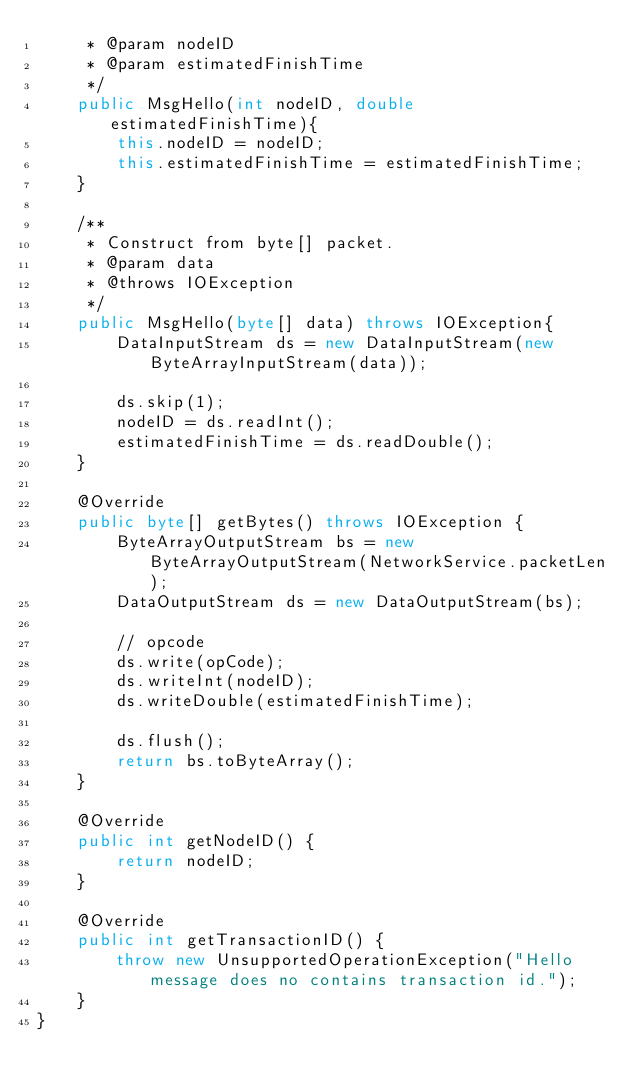<code> <loc_0><loc_0><loc_500><loc_500><_Java_>     * @param nodeID
     * @param estimatedFinishTime
     */
    public MsgHello(int nodeID, double estimatedFinishTime){
        this.nodeID = nodeID;
        this.estimatedFinishTime = estimatedFinishTime;
    }
    
    /**
     * Construct from byte[] packet.
     * @param data
     * @throws IOException 
     */
    public MsgHello(byte[] data) throws IOException{
        DataInputStream ds = new DataInputStream(new ByteArrayInputStream(data));
        
        ds.skip(1);
        nodeID = ds.readInt();
        estimatedFinishTime = ds.readDouble();
    }

    @Override
    public byte[] getBytes() throws IOException {
        ByteArrayOutputStream bs = new ByteArrayOutputStream(NetworkService.packetLen);
        DataOutputStream ds = new DataOutputStream(bs);
        
        // opcode
        ds.write(opCode);
        ds.writeInt(nodeID);
        ds.writeDouble(estimatedFinishTime);
        
        ds.flush();
        return bs.toByteArray();
    }

    @Override
    public int getNodeID() {
        return nodeID;
    }

    @Override
    public int getTransactionID() {
        throw new UnsupportedOperationException("Hello message does no contains transaction id."); 
    }
}
</code> 